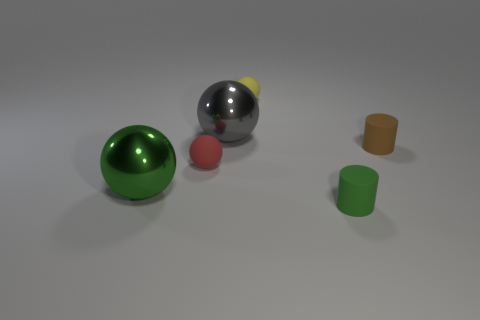There is a green sphere; is its size the same as the cylinder behind the green metal ball?
Your answer should be very brief. No. What shape is the tiny object on the left side of the tiny yellow sphere?
Ensure brevity in your answer.  Sphere. Are there any other things that have the same shape as the gray object?
Give a very brief answer. Yes. Are there any purple shiny objects?
Ensure brevity in your answer.  No. Is the size of the metallic object that is behind the green metal sphere the same as the green object that is on the right side of the tiny yellow sphere?
Make the answer very short. No. What material is the thing that is both in front of the red rubber sphere and behind the green cylinder?
Your response must be concise. Metal. How many tiny matte cylinders are right of the small yellow sphere?
Offer a very short reply. 2. There is a small cylinder that is the same material as the small brown object; what color is it?
Offer a very short reply. Green. Is the shape of the gray thing the same as the yellow rubber thing?
Your response must be concise. Yes. How many things are behind the green metallic object and on the left side of the gray object?
Keep it short and to the point. 1. 